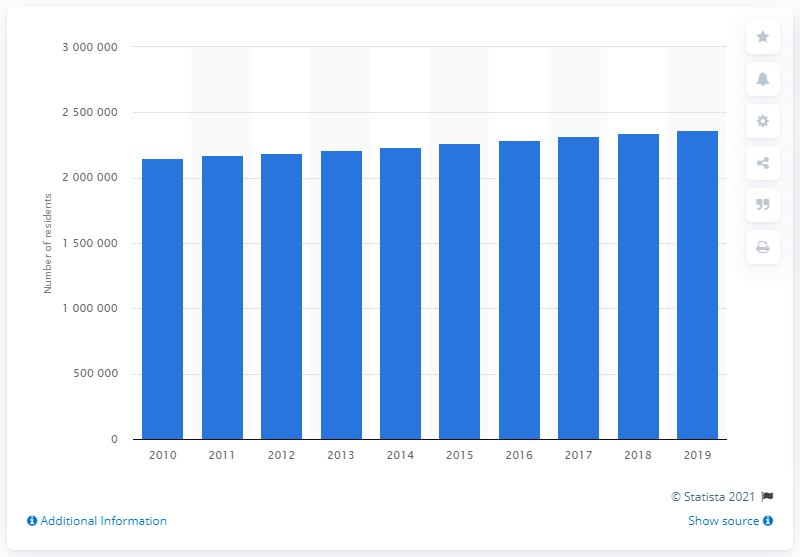Mention a couple of crucial points in this snapshot. In the year 2019, an estimated 234,1940 people lived in the Sacramento-Roseville-Arden-Arcade metropolitan area. 